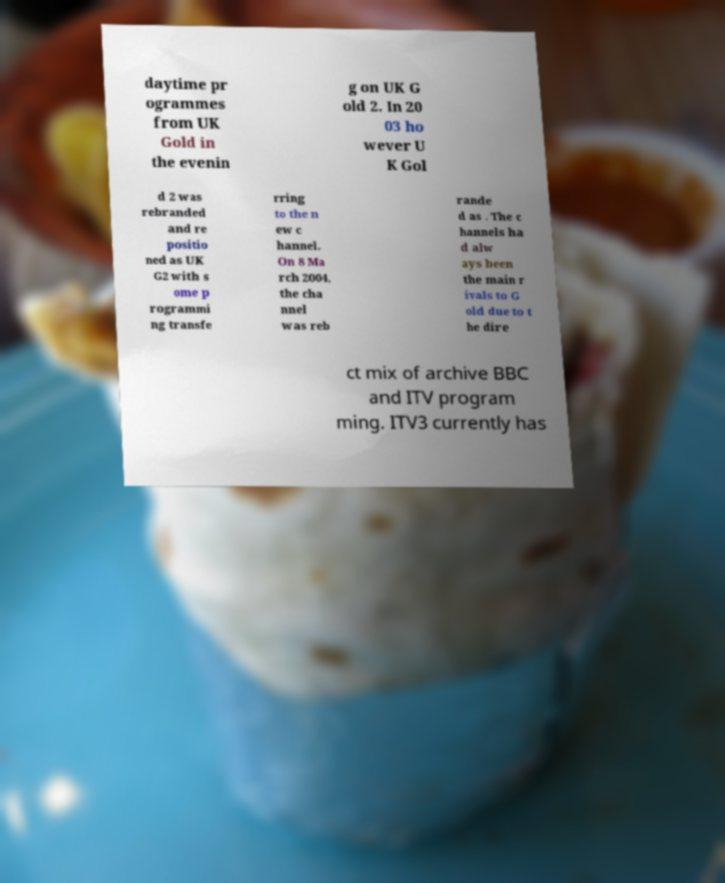Can you read and provide the text displayed in the image?This photo seems to have some interesting text. Can you extract and type it out for me? daytime pr ogrammes from UK Gold in the evenin g on UK G old 2. In 20 03 ho wever U K Gol d 2 was rebranded and re positio ned as UK G2 with s ome p rogrammi ng transfe rring to the n ew c hannel. On 8 Ma rch 2004, the cha nnel was reb rande d as . The c hannels ha d alw ays been the main r ivals to G old due to t he dire ct mix of archive BBC and ITV program ming. ITV3 currently has 